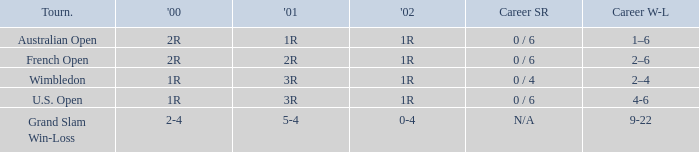Which career win-loss record has a 1r in 2002, a 2r in 2000 and a 2r in 2001? 2–6. 